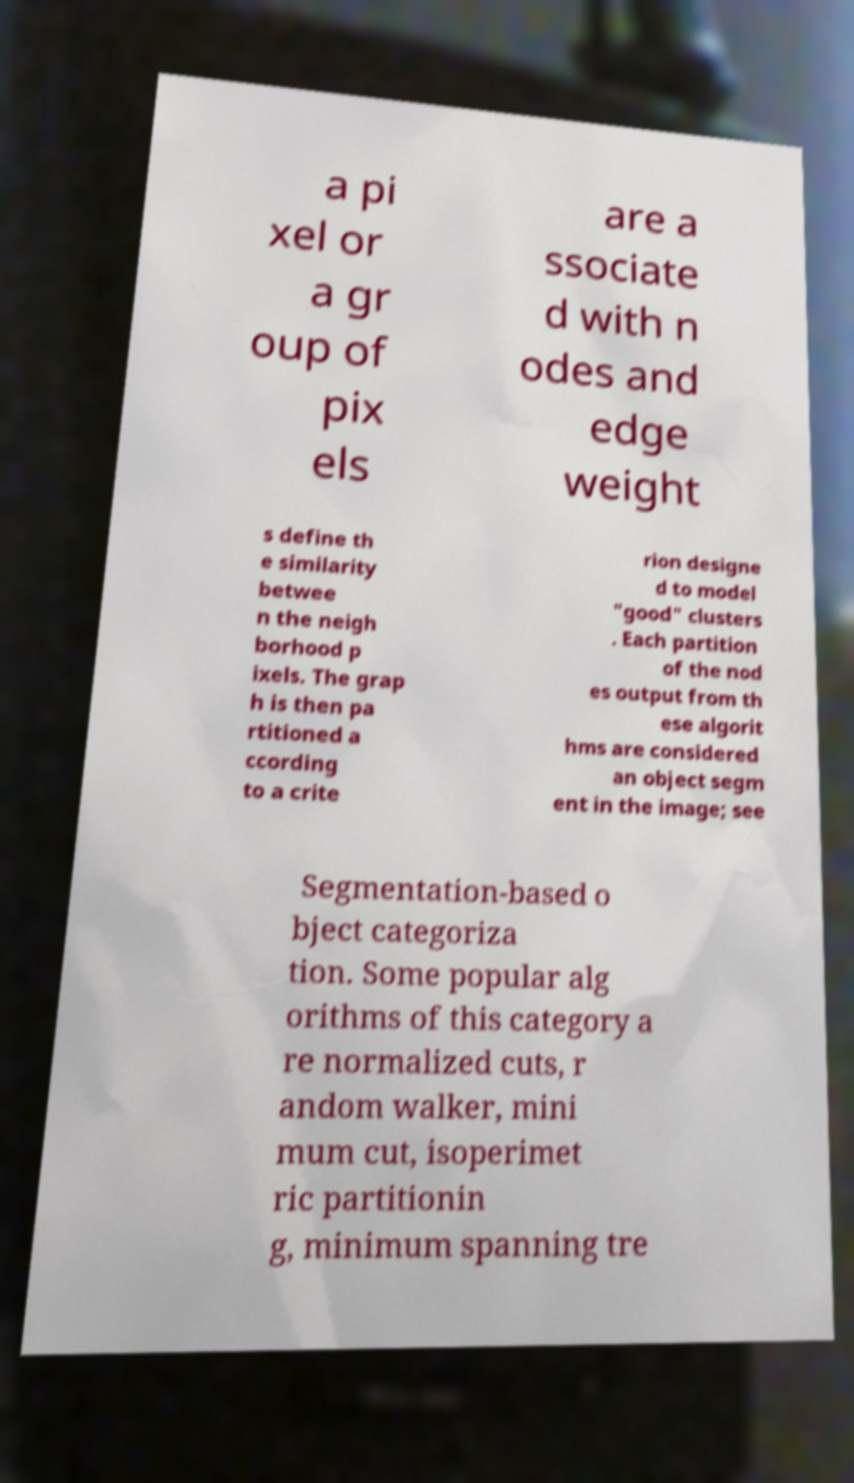I need the written content from this picture converted into text. Can you do that? a pi xel or a gr oup of pix els are a ssociate d with n odes and edge weight s define th e similarity betwee n the neigh borhood p ixels. The grap h is then pa rtitioned a ccording to a crite rion designe d to model "good" clusters . Each partition of the nod es output from th ese algorit hms are considered an object segm ent in the image; see Segmentation-based o bject categoriza tion. Some popular alg orithms of this category a re normalized cuts, r andom walker, mini mum cut, isoperimet ric partitionin g, minimum spanning tre 